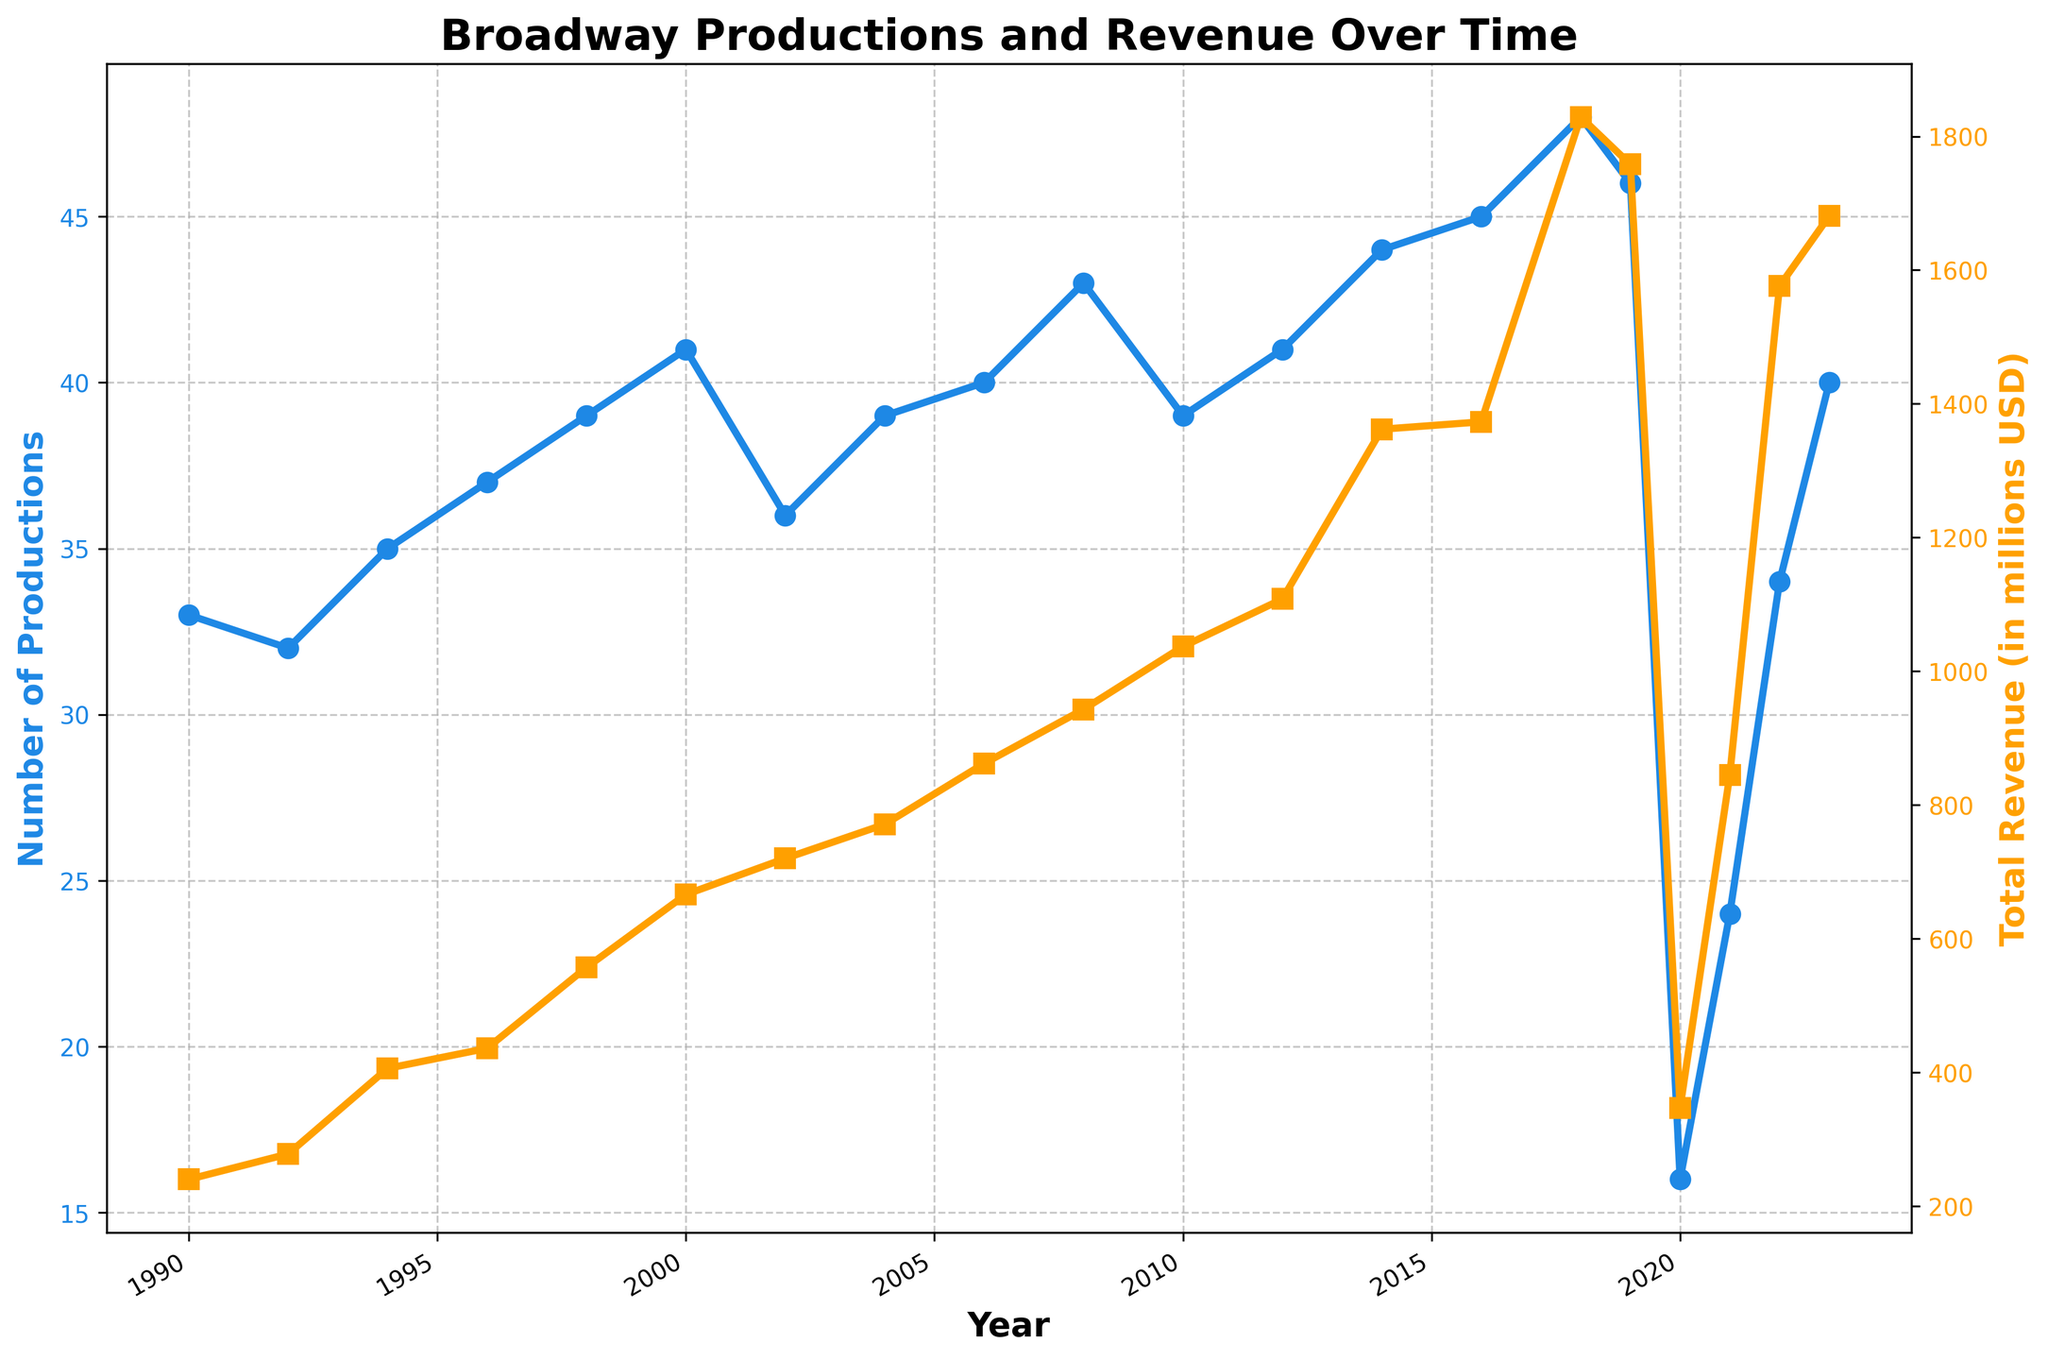How did the total revenue change between 2020 and 2021? In 2020, the total revenue was $347 million, and in 2021, it rose to $845 million. The change in revenue is calculated by finding the difference: $845 million - $347 million = $498 million.
Answer: $498 million What is the general trend in the number of Broadway productions from 1990 to 2023? By observing the blue line representing the number of productions, it can be seen that the number generally increases from 1990 to 2018, with a significant drop in 2020, followed by a recovery trend up to 2023.
Answer: Increasing trend with a drop in 2020 In which year did the number of Broadway productions and total revenue both reach a local maximum? Looking at the peaks of both lines, one can see that in 2018, there were 48 productions and the total revenue peaked at $1829 million.
Answer: 2018 Which year had the highest total revenue, and how much was it? According to the orange line, the peak value of total revenue is in 2018, where it reached $1829 million.
Answer: 2018, $1829 million Compare the number of productions in 1990 and 2023. Has there been an increase or decrease, and by how much? In 1990, there were 33 productions, and in 2023, there were 40 productions. The difference is 40 - 33 = 7, indicating an increase.
Answer: Increase by 7 productions What are the visual differences in the lines representing the number of productions and total revenue? The blue line with circles represents the number of productions, while the orange line with squares represents the total revenue. They are plotted on different y-axes, with the blue line on the left axis and the orange line on the right axis.
Answer: Different colors, markers, and axes How does the total revenue in 2022 compare to that in 2016? In 2016, the total revenue was $1373 million, whereas in 2022, it was $1576 million. Comparing these values, $1576 million - $1373 million = $203 million more in 2022.
Answer: $203 million more in 2022 What impact did the year 2020 have on Broadway productions and revenue compared to the surrounding years? The number of productions dropped significantly to 16, and the total revenue fell to $347 million in 2020. This is a stark contrast to the higher values in the surrounding years.
Answer: Significant drop in both productions and revenue 